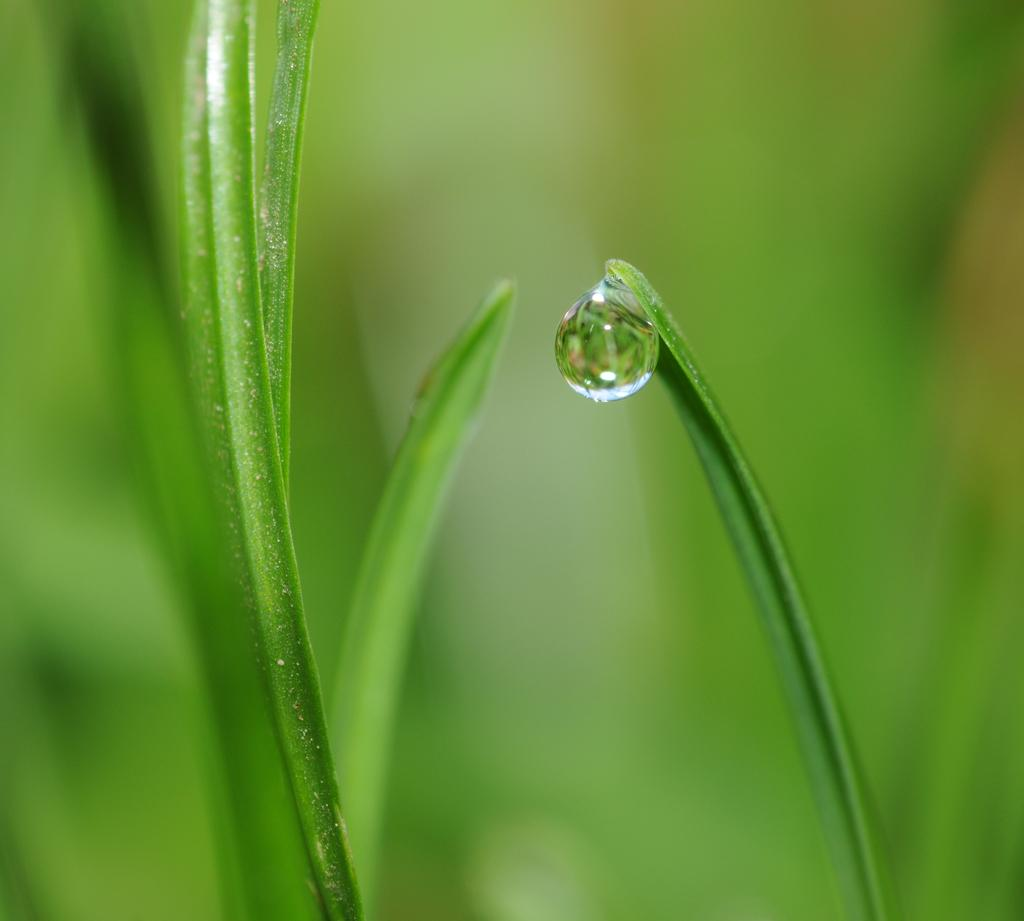What is the main subject of the image? The main subject of the image is a water drop. Where is the water drop located? The water drop is on a green leaf. What type of experience does the water drop have with the calendar in the image? There is no calendar present in the image, and therefore no such experience can be observed. What type of shirt is the water drop wearing in the image? The water drop is not a living being and does not wear clothing, such as a shirt. 